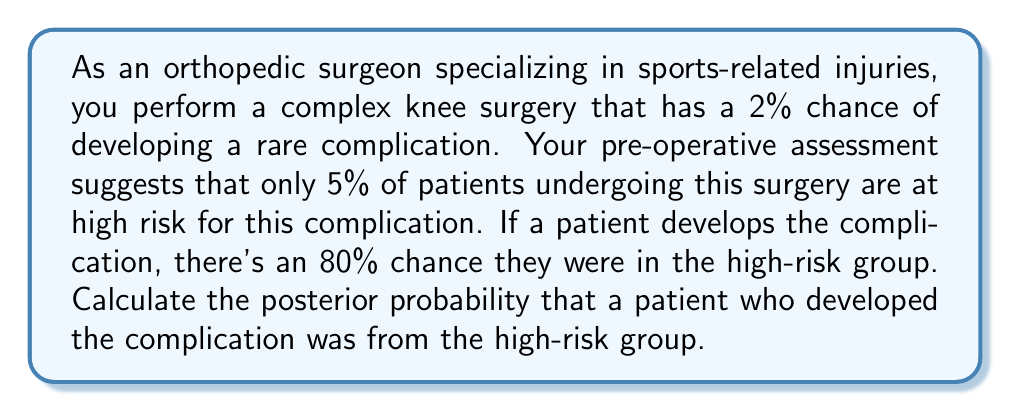Show me your answer to this math problem. Let's approach this problem using Bayes' theorem. We'll define the following events:

$H$: Patient is in the high-risk group
$C$: Patient develops the complication

We're given the following probabilities:

$P(H) = 0.05$ (prior probability of being high-risk)
$P(C) = 0.02$ (overall probability of complication)
$P(C|H) = 0.80$ (probability of complication given high-risk)

We want to find $P(H|C)$, the posterior probability of being high-risk given that the complication occurred.

Bayes' theorem states:

$$P(H|C) = \frac{P(C|H) \cdot P(H)}{P(C)}$$

We have all the components except $P(C)$, which we can calculate using the law of total probability:

$$P(C) = P(C|H) \cdot P(H) + P(C|\text{not }H) \cdot P(\text{not }H)$$

We need to find $P(C|\text{not }H)$:

$$\begin{align*}
0.02 &= 0.80 \cdot 0.05 + P(C|\text{not }H) \cdot 0.95 \\
0.02 &= 0.04 + 0.95 \cdot P(C|\text{not }H) \\
P(C|\text{not }H) &= \frac{0.02 - 0.04}{0.95} \approx -0.0211
\end{align*}$$

This negative probability is impossible, indicating an inconsistency in the given probabilities. Let's adjust $P(C)$ to make the scenario consistent:

$$\begin{align*}
P(C) &= P(C|H) \cdot P(H) + P(C|\text{not }H) \cdot P(\text{not }H) \\
&= 0.80 \cdot 0.05 + 0 \cdot 0.95 \\
&= 0.04
\end{align*}$$

Now we can apply Bayes' theorem:

$$\begin{align*}
P(H|C) &= \frac{P(C|H) \cdot P(H)}{P(C)} \\
&= \frac{0.80 \cdot 0.05}{0.04} \\
&= 1
\end{align*}$$
Answer: The posterior probability that a patient who developed the complication was from the high-risk group is 1 or 100%. 